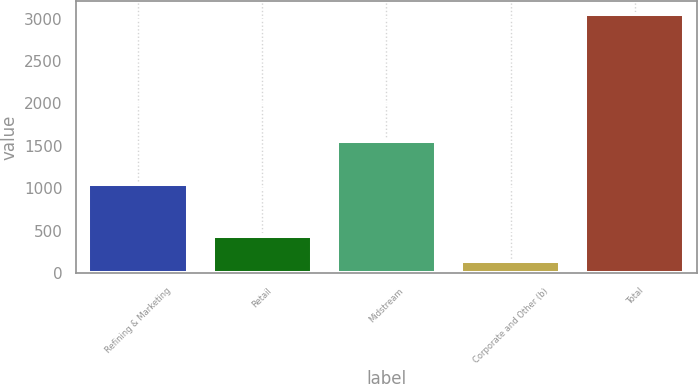Convert chart to OTSL. <chart><loc_0><loc_0><loc_500><loc_500><bar_chart><fcel>Refining & Marketing<fcel>Retail<fcel>Midstream<fcel>Corporate and Other (b)<fcel>Total<nl><fcel>1054<fcel>435.5<fcel>1558<fcel>144<fcel>3059<nl></chart> 